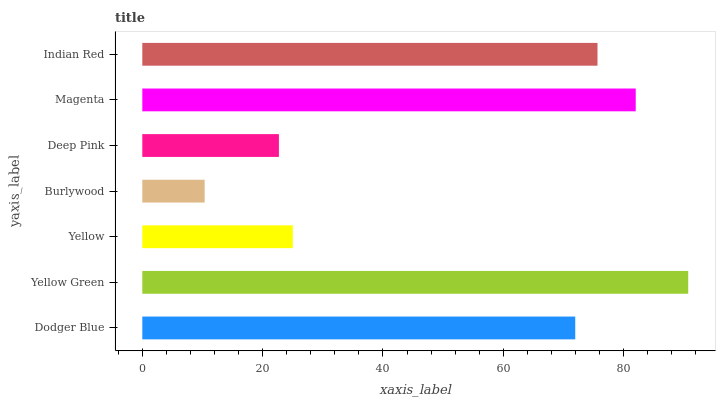Is Burlywood the minimum?
Answer yes or no. Yes. Is Yellow Green the maximum?
Answer yes or no. Yes. Is Yellow the minimum?
Answer yes or no. No. Is Yellow the maximum?
Answer yes or no. No. Is Yellow Green greater than Yellow?
Answer yes or no. Yes. Is Yellow less than Yellow Green?
Answer yes or no. Yes. Is Yellow greater than Yellow Green?
Answer yes or no. No. Is Yellow Green less than Yellow?
Answer yes or no. No. Is Dodger Blue the high median?
Answer yes or no. Yes. Is Dodger Blue the low median?
Answer yes or no. Yes. Is Yellow the high median?
Answer yes or no. No. Is Yellow Green the low median?
Answer yes or no. No. 